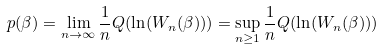<formula> <loc_0><loc_0><loc_500><loc_500>p ( \beta ) = \lim _ { n \to \infty } \frac { 1 } { n } Q ( \ln ( W _ { n } ( \beta ) ) ) = \sup _ { n \geq 1 } \frac { 1 } { n } Q ( \ln ( W _ { n } ( \beta ) ) )</formula> 